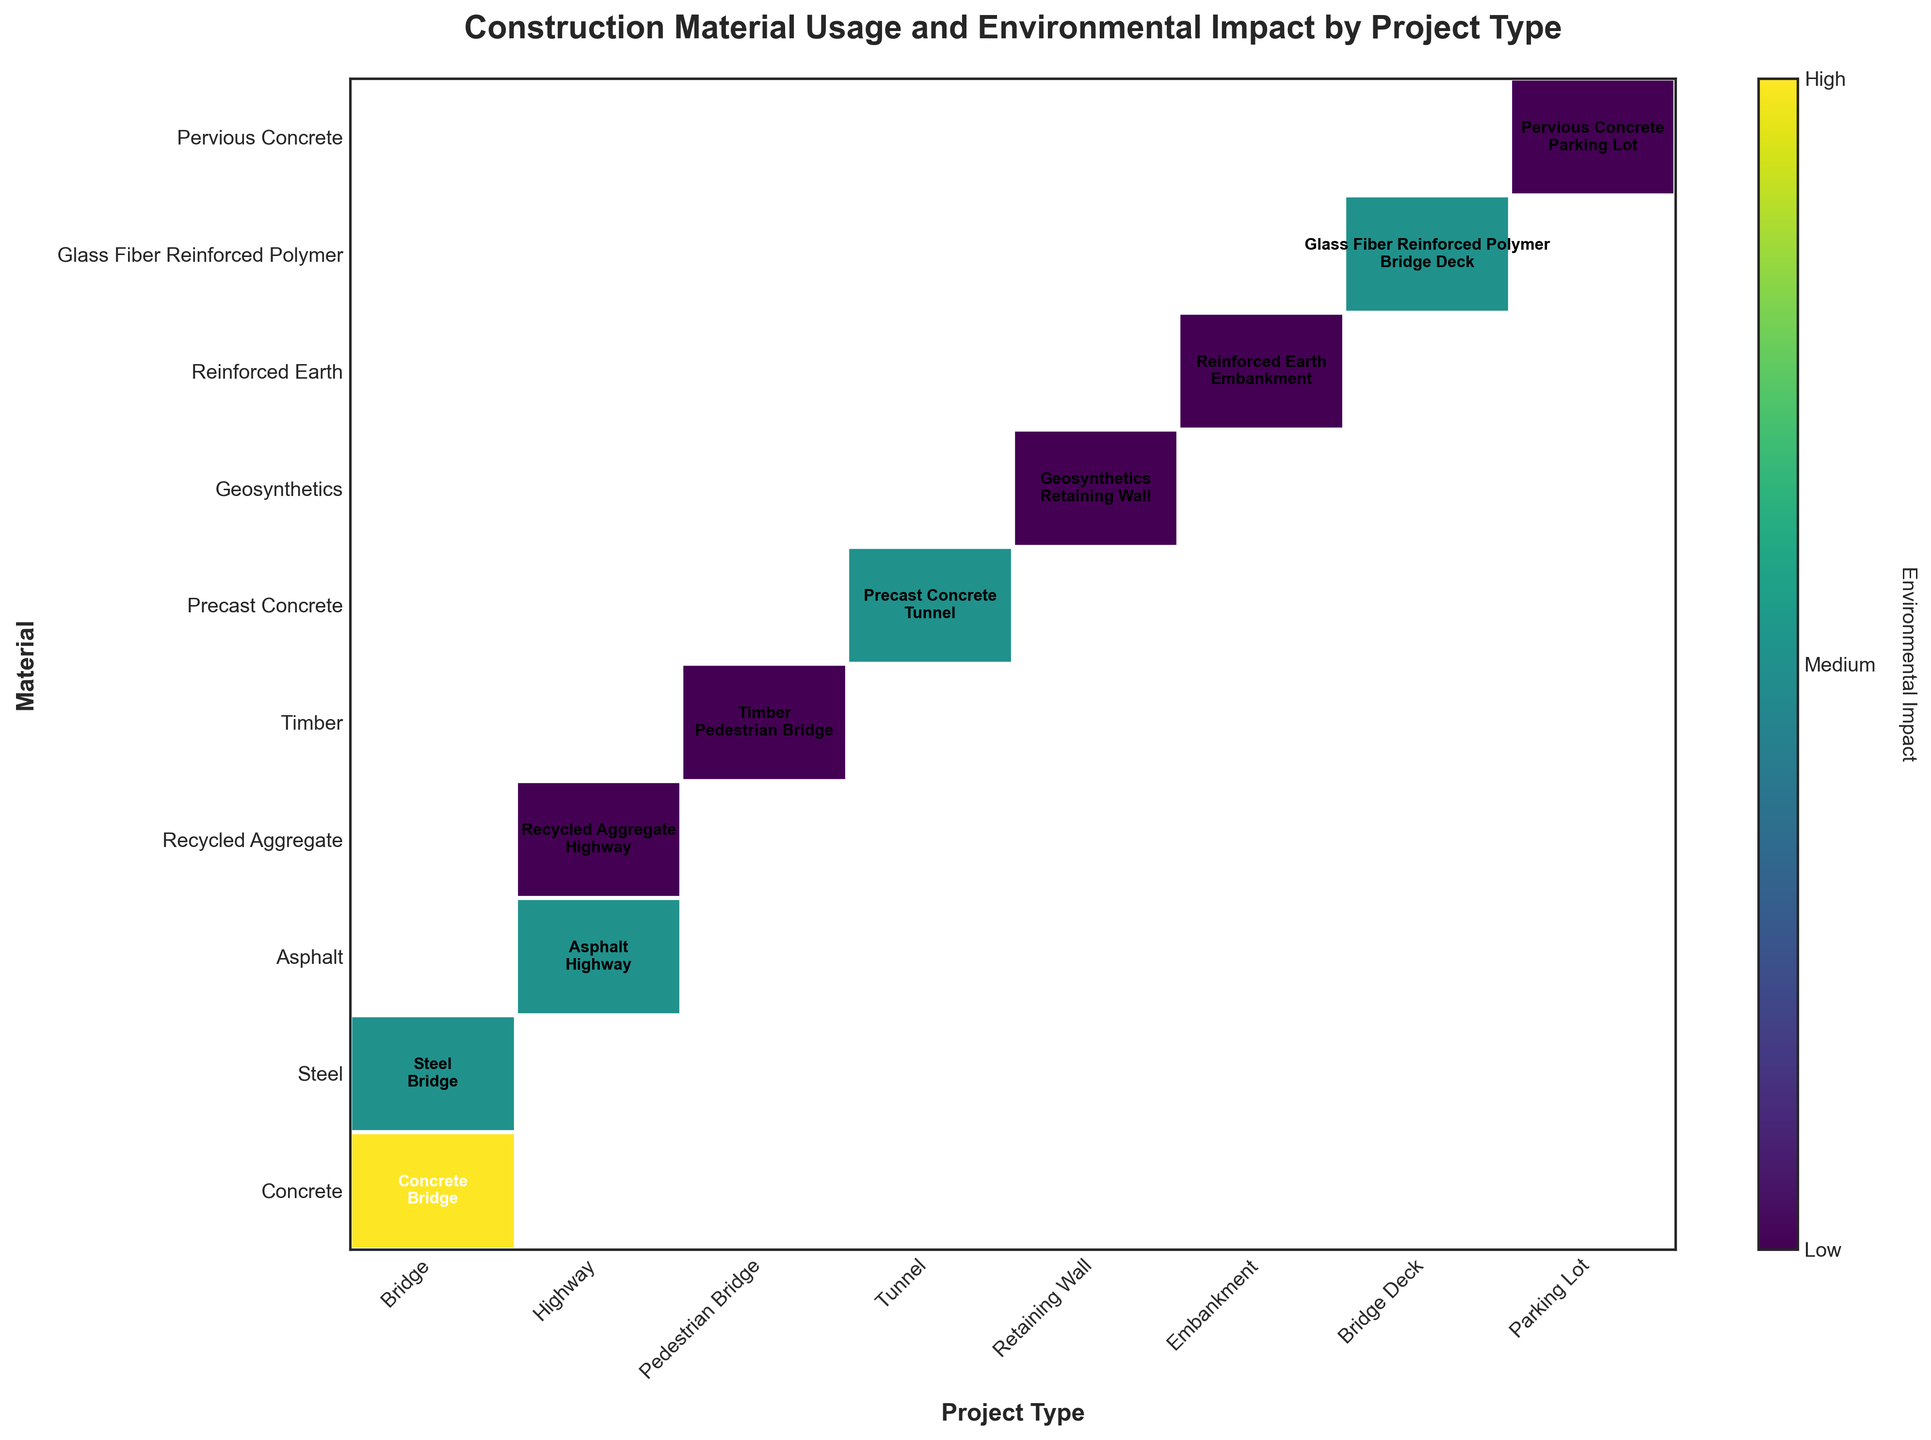Which project type has the highest environmental impact with frequent usage of materials? The figure has rectangles colored according to environmental impact, and the text in the rectangles indicates materials and project types with their usage frequencies. Look for the project type with the rectangle marked as "High" for environmental impact and "Frequent" for usage frequency. Identify that project type based on the visual elements.
Answer: Bridge How many materials are listed for pedestrian bridge projects? Identify the specific rows in the figure corresponding to the "Pedestrian Bridge" project type. Count the number of unique rectangles or texts associated with this project type.
Answer: 1 Which material associated with highway projects has the lowest environmental impact and what is its usage frequency? Identify the "Highway" project type from the list and locate all materials listed under it. Check their environmental impacts and find the one with the lowest impact. Then, verify its usage frequency based on the text in the rectangle.
Answer: Recycled Aggregate, Occasional Do tunnels predominantly use materials with medium environmental impact and frequent usage? Locate rectangles corresponding to the "Tunnel" project type. Note the colors indicating 'Medium' environmental impact, and check their usage frequencies marked in the text. A detailed count will be required.
Answer: Yes Which project type uses Perccrepid thevious Concrete the most frequently? Locate the rectangle corresponding to "Pervious Concrete". The project type will be mentioned within the text of the rectangle, and compare usage frequencies if there are multiple rectangles listed.
Answer: Parking Lot Which material used in bridge decks has a medium environmental impact but rare usage frequency? Locate the rectangles listing materials for the "Bridge Deck" project type. Identify the rectangle's color indicating a 'Medium' environmental impact and text that denotes its usage frequency as 'Rare'.
Answer: Glass Fiber Reinforced Polymer How many unique materials are plotted in the figure? Count all the unique text entries for materials along the figure's y-axis or within the rectangles. Each unique material name represents a unique material.
Answer: 10 Which project type exhibits the most diverse range of materials? Compare the number of unique rectangles within each project type's section. The count of unique materials listed within each section—identified by the texts—will provide the answer.
Answer: Bridge 